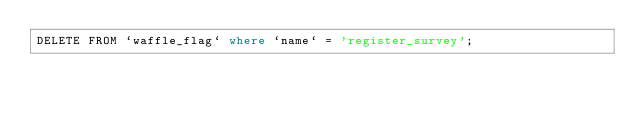<code> <loc_0><loc_0><loc_500><loc_500><_SQL_>DELETE FROM `waffle_flag` where `name` = 'register_survey';
</code> 